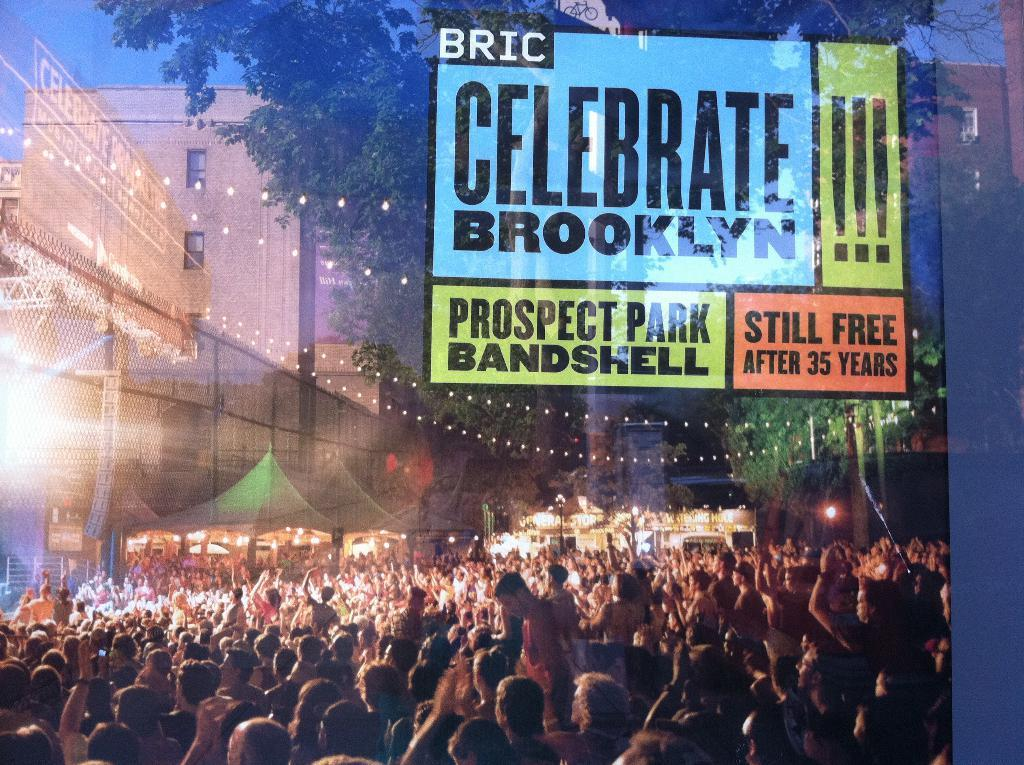<image>
Relay a brief, clear account of the picture shown. Ad showing a group of people with words that say "Celebrate Brooklyn". 